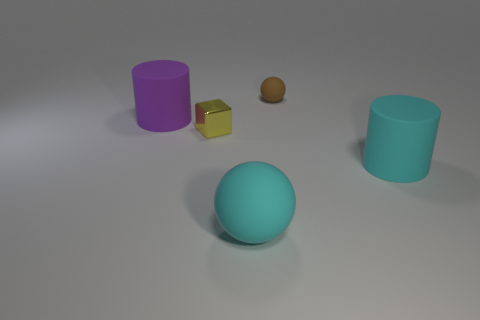Is there any other thing that is the same material as the cube?
Provide a short and direct response. No. Is the big cylinder that is on the left side of the large cyan cylinder made of the same material as the big cylinder on the right side of the brown matte object?
Your response must be concise. Yes. There is a thing that is to the right of the tiny brown object; what is its shape?
Give a very brief answer. Cylinder. How many things are either purple objects or large rubber things in front of the big purple rubber cylinder?
Offer a terse response. 3. Is the cube made of the same material as the brown thing?
Give a very brief answer. No. Are there an equal number of purple objects right of the large sphere and small things on the right side of the small brown matte thing?
Your response must be concise. Yes. There is a tiny brown rubber ball; what number of small yellow shiny cubes are behind it?
Your answer should be very brief. 0. How many objects are either large spheres or metal objects?
Provide a succinct answer. 2. What number of cyan rubber cylinders are the same size as the brown thing?
Keep it short and to the point. 0. What shape is the small thing behind the big cylinder that is behind the metallic object?
Make the answer very short. Sphere. 